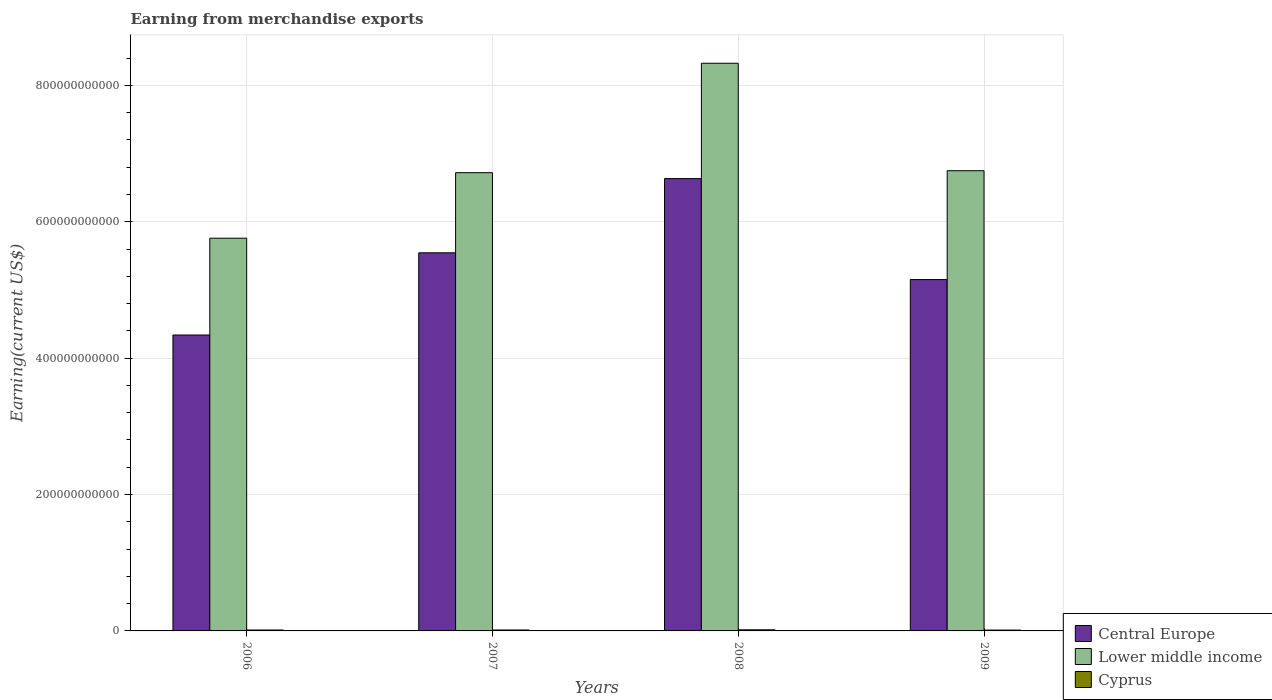How many different coloured bars are there?
Provide a short and direct response. 3. How many groups of bars are there?
Give a very brief answer. 4. Are the number of bars per tick equal to the number of legend labels?
Your answer should be compact. Yes. Are the number of bars on each tick of the X-axis equal?
Your answer should be very brief. Yes. How many bars are there on the 4th tick from the left?
Provide a short and direct response. 3. How many bars are there on the 3rd tick from the right?
Provide a succinct answer. 3. What is the label of the 2nd group of bars from the left?
Keep it short and to the point. 2007. In how many cases, is the number of bars for a given year not equal to the number of legend labels?
Ensure brevity in your answer.  0. What is the amount earned from merchandise exports in Central Europe in 2007?
Provide a succinct answer. 5.54e+11. Across all years, what is the maximum amount earned from merchandise exports in Lower middle income?
Make the answer very short. 8.32e+11. Across all years, what is the minimum amount earned from merchandise exports in Lower middle income?
Provide a succinct answer. 5.76e+11. In which year was the amount earned from merchandise exports in Cyprus minimum?
Make the answer very short. 2009. What is the total amount earned from merchandise exports in Central Europe in the graph?
Make the answer very short. 2.17e+12. What is the difference between the amount earned from merchandise exports in Cyprus in 2007 and that in 2009?
Offer a terse response. 1.37e+08. What is the difference between the amount earned from merchandise exports in Lower middle income in 2009 and the amount earned from merchandise exports in Central Europe in 2006?
Your response must be concise. 2.41e+11. What is the average amount earned from merchandise exports in Central Europe per year?
Your response must be concise. 5.42e+11. In the year 2006, what is the difference between the amount earned from merchandise exports in Central Europe and amount earned from merchandise exports in Cyprus?
Keep it short and to the point. 4.33e+11. In how many years, is the amount earned from merchandise exports in Central Europe greater than 720000000000 US$?
Ensure brevity in your answer.  0. What is the ratio of the amount earned from merchandise exports in Central Europe in 2006 to that in 2008?
Your answer should be very brief. 0.65. Is the amount earned from merchandise exports in Central Europe in 2008 less than that in 2009?
Provide a short and direct response. No. Is the difference between the amount earned from merchandise exports in Central Europe in 2006 and 2007 greater than the difference between the amount earned from merchandise exports in Cyprus in 2006 and 2007?
Keep it short and to the point. No. What is the difference between the highest and the second highest amount earned from merchandise exports in Cyprus?
Provide a succinct answer. 2.39e+08. What is the difference between the highest and the lowest amount earned from merchandise exports in Lower middle income?
Your response must be concise. 2.57e+11. In how many years, is the amount earned from merchandise exports in Central Europe greater than the average amount earned from merchandise exports in Central Europe taken over all years?
Make the answer very short. 2. What does the 1st bar from the left in 2008 represents?
Your answer should be compact. Central Europe. What does the 1st bar from the right in 2008 represents?
Provide a succinct answer. Cyprus. Is it the case that in every year, the sum of the amount earned from merchandise exports in Central Europe and amount earned from merchandise exports in Cyprus is greater than the amount earned from merchandise exports in Lower middle income?
Your answer should be very brief. No. How many years are there in the graph?
Your response must be concise. 4. What is the difference between two consecutive major ticks on the Y-axis?
Provide a short and direct response. 2.00e+11. Are the values on the major ticks of Y-axis written in scientific E-notation?
Your answer should be very brief. No. Does the graph contain any zero values?
Make the answer very short. No. Where does the legend appear in the graph?
Give a very brief answer. Bottom right. How many legend labels are there?
Your response must be concise. 3. What is the title of the graph?
Keep it short and to the point. Earning from merchandise exports. Does "Barbados" appear as one of the legend labels in the graph?
Ensure brevity in your answer.  No. What is the label or title of the Y-axis?
Your response must be concise. Earning(current US$). What is the Earning(current US$) of Central Europe in 2006?
Offer a very short reply. 4.34e+11. What is the Earning(current US$) of Lower middle income in 2006?
Make the answer very short. 5.76e+11. What is the Earning(current US$) in Cyprus in 2006?
Provide a succinct answer. 1.33e+09. What is the Earning(current US$) in Central Europe in 2007?
Provide a short and direct response. 5.54e+11. What is the Earning(current US$) of Lower middle income in 2007?
Ensure brevity in your answer.  6.72e+11. What is the Earning(current US$) in Cyprus in 2007?
Your answer should be very brief. 1.39e+09. What is the Earning(current US$) of Central Europe in 2008?
Keep it short and to the point. 6.63e+11. What is the Earning(current US$) of Lower middle income in 2008?
Offer a very short reply. 8.32e+11. What is the Earning(current US$) in Cyprus in 2008?
Your response must be concise. 1.63e+09. What is the Earning(current US$) of Central Europe in 2009?
Your response must be concise. 5.15e+11. What is the Earning(current US$) of Lower middle income in 2009?
Make the answer very short. 6.75e+11. What is the Earning(current US$) in Cyprus in 2009?
Your answer should be very brief. 1.26e+09. Across all years, what is the maximum Earning(current US$) in Central Europe?
Offer a terse response. 6.63e+11. Across all years, what is the maximum Earning(current US$) in Lower middle income?
Your answer should be compact. 8.32e+11. Across all years, what is the maximum Earning(current US$) in Cyprus?
Offer a very short reply. 1.63e+09. Across all years, what is the minimum Earning(current US$) of Central Europe?
Ensure brevity in your answer.  4.34e+11. Across all years, what is the minimum Earning(current US$) of Lower middle income?
Provide a short and direct response. 5.76e+11. Across all years, what is the minimum Earning(current US$) of Cyprus?
Keep it short and to the point. 1.26e+09. What is the total Earning(current US$) in Central Europe in the graph?
Offer a very short reply. 2.17e+12. What is the total Earning(current US$) in Lower middle income in the graph?
Your answer should be compact. 2.76e+12. What is the total Earning(current US$) of Cyprus in the graph?
Keep it short and to the point. 5.62e+09. What is the difference between the Earning(current US$) in Central Europe in 2006 and that in 2007?
Make the answer very short. -1.21e+11. What is the difference between the Earning(current US$) of Lower middle income in 2006 and that in 2007?
Give a very brief answer. -9.61e+1. What is the difference between the Earning(current US$) of Cyprus in 2006 and that in 2007?
Give a very brief answer. -6.09e+07. What is the difference between the Earning(current US$) of Central Europe in 2006 and that in 2008?
Give a very brief answer. -2.29e+11. What is the difference between the Earning(current US$) in Lower middle income in 2006 and that in 2008?
Keep it short and to the point. -2.57e+11. What is the difference between the Earning(current US$) of Cyprus in 2006 and that in 2008?
Offer a terse response. -3.00e+08. What is the difference between the Earning(current US$) of Central Europe in 2006 and that in 2009?
Your answer should be compact. -8.13e+1. What is the difference between the Earning(current US$) in Lower middle income in 2006 and that in 2009?
Offer a terse response. -9.90e+1. What is the difference between the Earning(current US$) in Cyprus in 2006 and that in 2009?
Your answer should be very brief. 7.58e+07. What is the difference between the Earning(current US$) in Central Europe in 2007 and that in 2008?
Your answer should be compact. -1.09e+11. What is the difference between the Earning(current US$) of Lower middle income in 2007 and that in 2008?
Your response must be concise. -1.60e+11. What is the difference between the Earning(current US$) of Cyprus in 2007 and that in 2008?
Your answer should be compact. -2.39e+08. What is the difference between the Earning(current US$) in Central Europe in 2007 and that in 2009?
Offer a very short reply. 3.93e+1. What is the difference between the Earning(current US$) of Lower middle income in 2007 and that in 2009?
Make the answer very short. -2.90e+09. What is the difference between the Earning(current US$) in Cyprus in 2007 and that in 2009?
Keep it short and to the point. 1.37e+08. What is the difference between the Earning(current US$) in Central Europe in 2008 and that in 2009?
Offer a very short reply. 1.48e+11. What is the difference between the Earning(current US$) in Lower middle income in 2008 and that in 2009?
Offer a terse response. 1.58e+11. What is the difference between the Earning(current US$) of Cyprus in 2008 and that in 2009?
Offer a very short reply. 3.76e+08. What is the difference between the Earning(current US$) of Central Europe in 2006 and the Earning(current US$) of Lower middle income in 2007?
Your response must be concise. -2.38e+11. What is the difference between the Earning(current US$) in Central Europe in 2006 and the Earning(current US$) in Cyprus in 2007?
Offer a terse response. 4.33e+11. What is the difference between the Earning(current US$) of Lower middle income in 2006 and the Earning(current US$) of Cyprus in 2007?
Your response must be concise. 5.74e+11. What is the difference between the Earning(current US$) of Central Europe in 2006 and the Earning(current US$) of Lower middle income in 2008?
Your response must be concise. -3.98e+11. What is the difference between the Earning(current US$) in Central Europe in 2006 and the Earning(current US$) in Cyprus in 2008?
Offer a very short reply. 4.32e+11. What is the difference between the Earning(current US$) in Lower middle income in 2006 and the Earning(current US$) in Cyprus in 2008?
Provide a succinct answer. 5.74e+11. What is the difference between the Earning(current US$) of Central Europe in 2006 and the Earning(current US$) of Lower middle income in 2009?
Your answer should be compact. -2.41e+11. What is the difference between the Earning(current US$) in Central Europe in 2006 and the Earning(current US$) in Cyprus in 2009?
Ensure brevity in your answer.  4.33e+11. What is the difference between the Earning(current US$) of Lower middle income in 2006 and the Earning(current US$) of Cyprus in 2009?
Your answer should be compact. 5.75e+11. What is the difference between the Earning(current US$) in Central Europe in 2007 and the Earning(current US$) in Lower middle income in 2008?
Your response must be concise. -2.78e+11. What is the difference between the Earning(current US$) in Central Europe in 2007 and the Earning(current US$) in Cyprus in 2008?
Provide a succinct answer. 5.53e+11. What is the difference between the Earning(current US$) of Lower middle income in 2007 and the Earning(current US$) of Cyprus in 2008?
Your answer should be very brief. 6.70e+11. What is the difference between the Earning(current US$) of Central Europe in 2007 and the Earning(current US$) of Lower middle income in 2009?
Your answer should be very brief. -1.20e+11. What is the difference between the Earning(current US$) in Central Europe in 2007 and the Earning(current US$) in Cyprus in 2009?
Provide a succinct answer. 5.53e+11. What is the difference between the Earning(current US$) of Lower middle income in 2007 and the Earning(current US$) of Cyprus in 2009?
Provide a short and direct response. 6.71e+11. What is the difference between the Earning(current US$) in Central Europe in 2008 and the Earning(current US$) in Lower middle income in 2009?
Offer a very short reply. -1.16e+1. What is the difference between the Earning(current US$) in Central Europe in 2008 and the Earning(current US$) in Cyprus in 2009?
Ensure brevity in your answer.  6.62e+11. What is the difference between the Earning(current US$) of Lower middle income in 2008 and the Earning(current US$) of Cyprus in 2009?
Your answer should be very brief. 8.31e+11. What is the average Earning(current US$) of Central Europe per year?
Offer a terse response. 5.42e+11. What is the average Earning(current US$) in Lower middle income per year?
Offer a very short reply. 6.89e+11. What is the average Earning(current US$) of Cyprus per year?
Your answer should be compact. 1.40e+09. In the year 2006, what is the difference between the Earning(current US$) of Central Europe and Earning(current US$) of Lower middle income?
Your answer should be very brief. -1.42e+11. In the year 2006, what is the difference between the Earning(current US$) of Central Europe and Earning(current US$) of Cyprus?
Provide a succinct answer. 4.33e+11. In the year 2006, what is the difference between the Earning(current US$) in Lower middle income and Earning(current US$) in Cyprus?
Your answer should be very brief. 5.75e+11. In the year 2007, what is the difference between the Earning(current US$) of Central Europe and Earning(current US$) of Lower middle income?
Your answer should be compact. -1.17e+11. In the year 2007, what is the difference between the Earning(current US$) in Central Europe and Earning(current US$) in Cyprus?
Offer a terse response. 5.53e+11. In the year 2007, what is the difference between the Earning(current US$) in Lower middle income and Earning(current US$) in Cyprus?
Your answer should be compact. 6.71e+11. In the year 2008, what is the difference between the Earning(current US$) of Central Europe and Earning(current US$) of Lower middle income?
Your answer should be compact. -1.69e+11. In the year 2008, what is the difference between the Earning(current US$) in Central Europe and Earning(current US$) in Cyprus?
Keep it short and to the point. 6.62e+11. In the year 2008, what is the difference between the Earning(current US$) of Lower middle income and Earning(current US$) of Cyprus?
Your answer should be very brief. 8.31e+11. In the year 2009, what is the difference between the Earning(current US$) in Central Europe and Earning(current US$) in Lower middle income?
Ensure brevity in your answer.  -1.60e+11. In the year 2009, what is the difference between the Earning(current US$) in Central Europe and Earning(current US$) in Cyprus?
Offer a terse response. 5.14e+11. In the year 2009, what is the difference between the Earning(current US$) of Lower middle income and Earning(current US$) of Cyprus?
Your response must be concise. 6.74e+11. What is the ratio of the Earning(current US$) in Central Europe in 2006 to that in 2007?
Make the answer very short. 0.78. What is the ratio of the Earning(current US$) of Lower middle income in 2006 to that in 2007?
Make the answer very short. 0.86. What is the ratio of the Earning(current US$) of Cyprus in 2006 to that in 2007?
Your answer should be compact. 0.96. What is the ratio of the Earning(current US$) in Central Europe in 2006 to that in 2008?
Your response must be concise. 0.65. What is the ratio of the Earning(current US$) of Lower middle income in 2006 to that in 2008?
Your answer should be compact. 0.69. What is the ratio of the Earning(current US$) in Cyprus in 2006 to that in 2008?
Offer a very short reply. 0.82. What is the ratio of the Earning(current US$) of Central Europe in 2006 to that in 2009?
Provide a short and direct response. 0.84. What is the ratio of the Earning(current US$) of Lower middle income in 2006 to that in 2009?
Offer a terse response. 0.85. What is the ratio of the Earning(current US$) of Cyprus in 2006 to that in 2009?
Provide a succinct answer. 1.06. What is the ratio of the Earning(current US$) in Central Europe in 2007 to that in 2008?
Your answer should be very brief. 0.84. What is the ratio of the Earning(current US$) of Lower middle income in 2007 to that in 2008?
Provide a succinct answer. 0.81. What is the ratio of the Earning(current US$) of Cyprus in 2007 to that in 2008?
Your answer should be very brief. 0.85. What is the ratio of the Earning(current US$) in Central Europe in 2007 to that in 2009?
Your response must be concise. 1.08. What is the ratio of the Earning(current US$) in Lower middle income in 2007 to that in 2009?
Give a very brief answer. 1. What is the ratio of the Earning(current US$) of Cyprus in 2007 to that in 2009?
Ensure brevity in your answer.  1.11. What is the ratio of the Earning(current US$) of Central Europe in 2008 to that in 2009?
Provide a succinct answer. 1.29. What is the ratio of the Earning(current US$) in Lower middle income in 2008 to that in 2009?
Offer a very short reply. 1.23. What is the ratio of the Earning(current US$) of Cyprus in 2008 to that in 2009?
Make the answer very short. 1.3. What is the difference between the highest and the second highest Earning(current US$) of Central Europe?
Your answer should be compact. 1.09e+11. What is the difference between the highest and the second highest Earning(current US$) of Lower middle income?
Make the answer very short. 1.58e+11. What is the difference between the highest and the second highest Earning(current US$) in Cyprus?
Your answer should be compact. 2.39e+08. What is the difference between the highest and the lowest Earning(current US$) in Central Europe?
Keep it short and to the point. 2.29e+11. What is the difference between the highest and the lowest Earning(current US$) in Lower middle income?
Provide a succinct answer. 2.57e+11. What is the difference between the highest and the lowest Earning(current US$) in Cyprus?
Your answer should be very brief. 3.76e+08. 